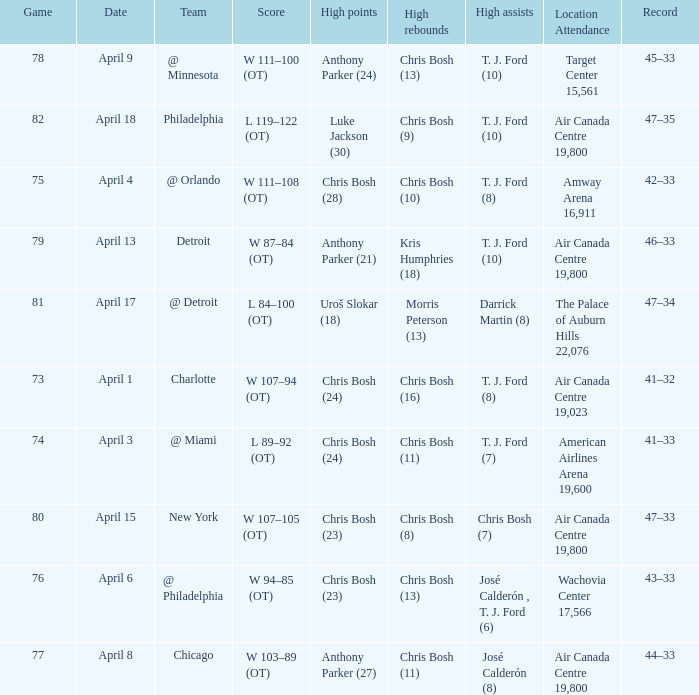What was the score of game 82? L 119–122 (OT). 